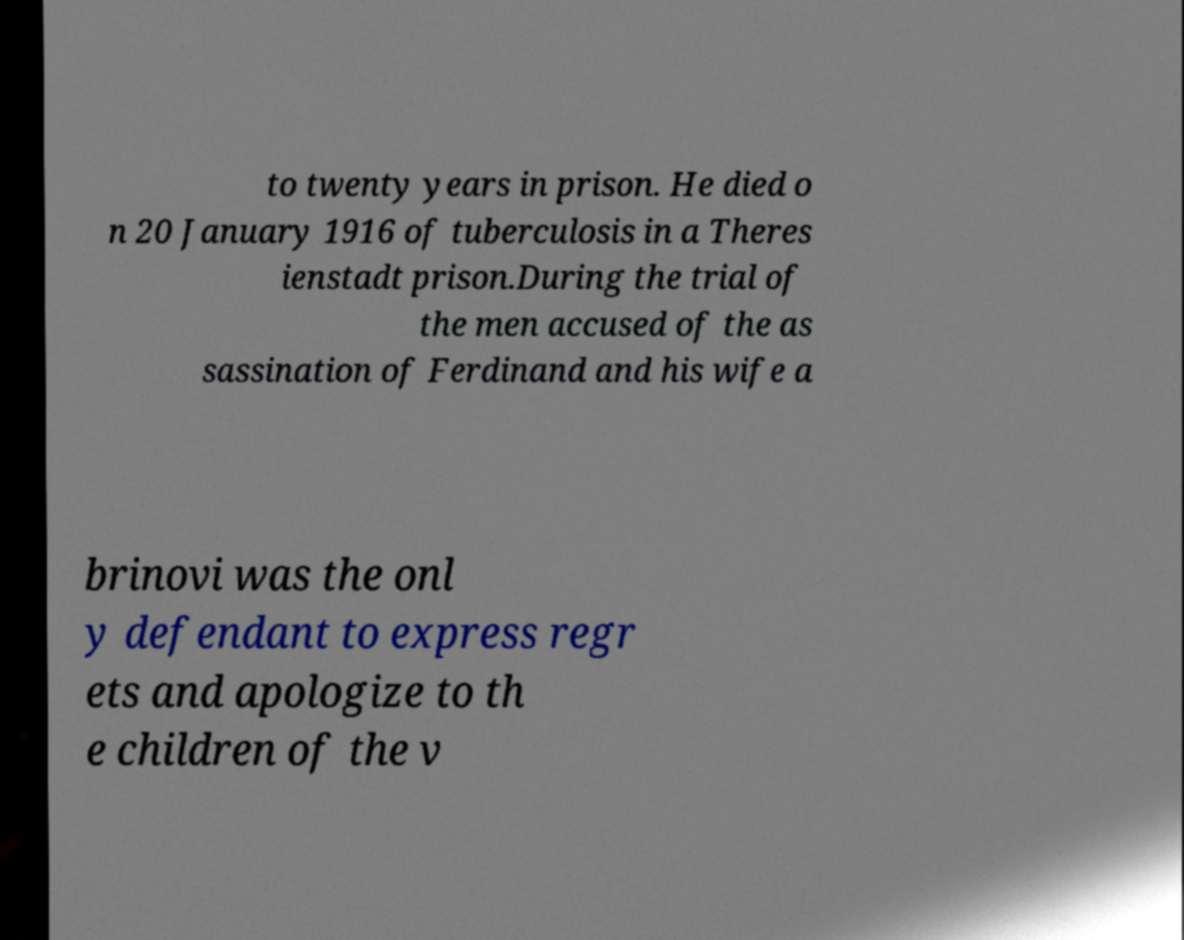Could you extract and type out the text from this image? to twenty years in prison. He died o n 20 January 1916 of tuberculosis in a Theres ienstadt prison.During the trial of the men accused of the as sassination of Ferdinand and his wife a brinovi was the onl y defendant to express regr ets and apologize to th e children of the v 